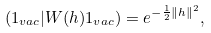Convert formula to latex. <formula><loc_0><loc_0><loc_500><loc_500>\left ( 1 _ { v a c } | W ( h ) 1 _ { v a c } \right ) = e ^ { - \frac { 1 } { 2 } \left \| h \right \| ^ { 2 } } ,</formula> 